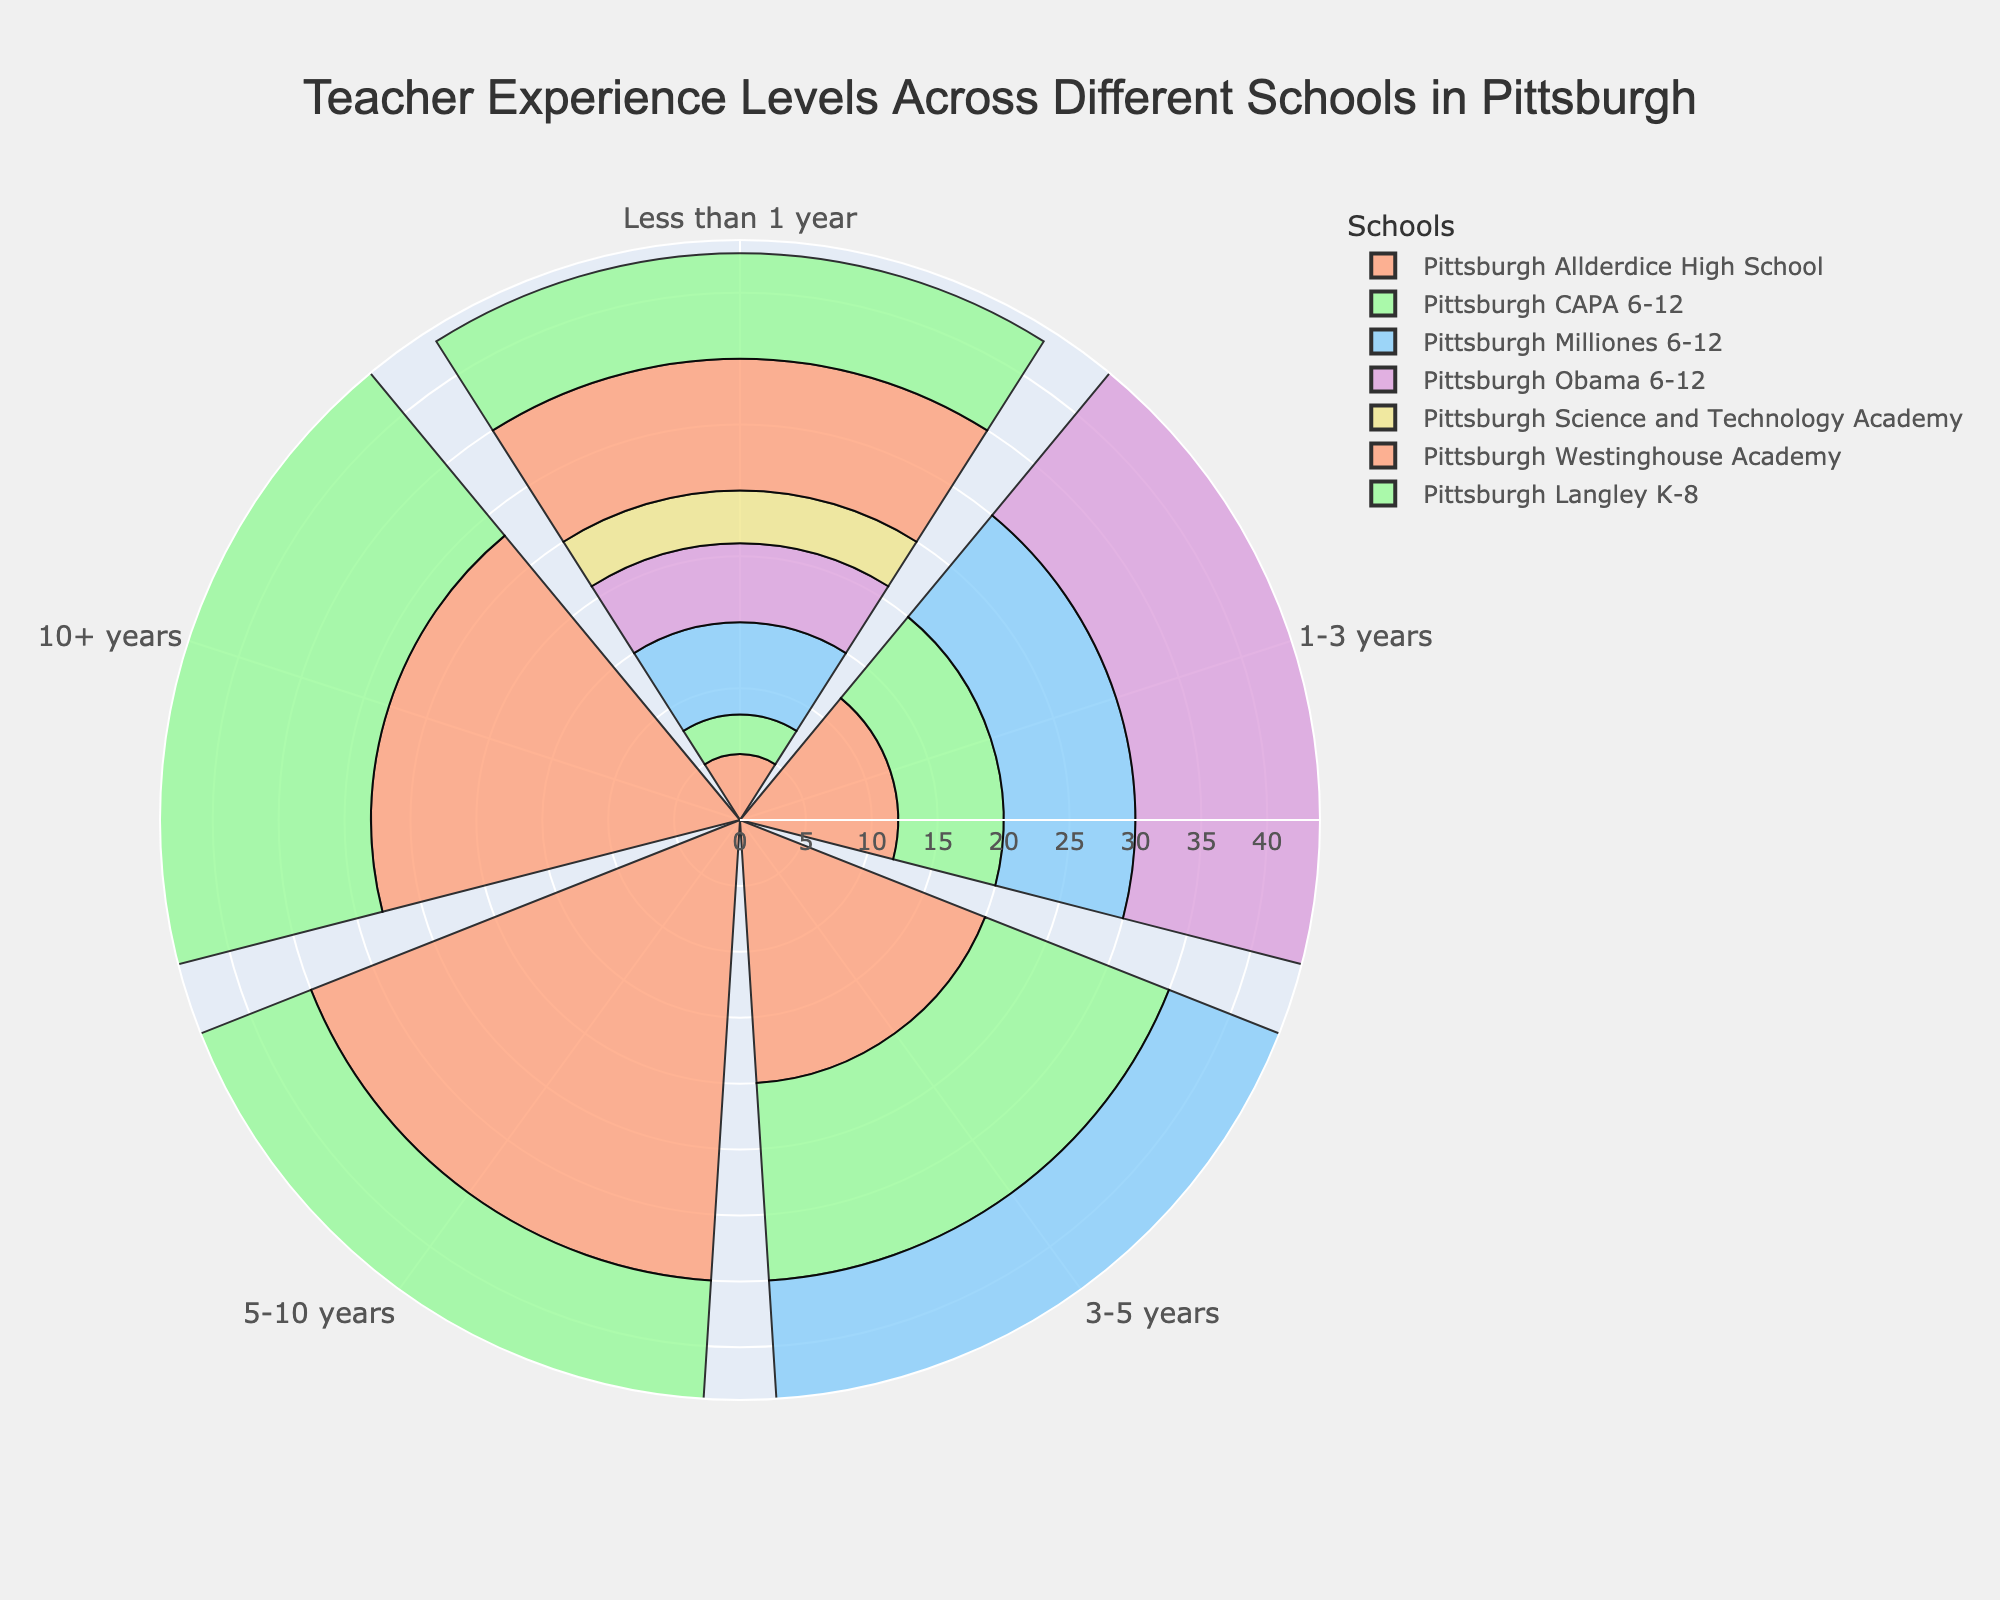What is the title of the figure? The title is prominently displayed at the top of the figure in larger, bold text.
Answer: Teacher Experience Levels Across Different Schools in Pittsburgh How many schools are represented in the figure? The figure's legend lists all the schools, and there are seven different colored segments representing each school.
Answer: Seven Which school has the highest number of teachers with more than 10 years of experience? By checking the length of the outermost segments in the rose chart, the school with the longest segment in the 10+ years category is Pittsburgh Westinghouse Academy.
Answer: Pittsburgh Westinghouse Academy For Pittsburgh CAPA 6-12, what is the total number of teachers with less than 5 years of experience? Add up the values from the segments representing "Less than 1 year," "1-3 years," and "3-5 years" for Pittsburgh CAPA 6-12: 3 + 8 + 15.
Answer: 26 Which school has the greatest difference in the number of teachers between the "1-3 years" and "5-10 years" experience categories? Calculate the differences for each school: 
Pittsburgh Allderdice High School = 35 - 12 = 23, 
Pittsburgh CAPA 6-12 = 25 - 8 = 17, 
Pittsburgh Milliones 6-12 = 25 - 10 = 15, 
Pittsburgh Obama 6-12 = 30 - 15 = 15, 
Pittsburgh Science and Technology Academy = 28 - 10 = 18, 
Pittsburgh Westinghouse Academy = 35 - 18 = 17,
Pittsburgh Langley K-8 = 20 - 16 = 4;
Pittsburgh Allderdice High School has the greatest difference.
Answer: Pittsburgh Allderdice High School Which school has the smallest portion of teachers with "Less than 1 year" of experience? The smallest innermost segment represents the school with the least teachers in this category, which is Pittsburgh CAPA 6-12.
Answer: Pittsburgh CAPA 6-12 Between Pittsburgh Science and Technology Academy and Pittsburgh Milliones 6-12, which school has more teachers with "5-10 years" of experience? Compare the length of the 5-10 years segments for both schools; Pittsburgh Science and Technology Academy has 28 while Pittsburgh Milliones 6-12 has 25.
Answer: Pittsburgh Science and Technology Academy What is the average number of teachers with "3-5 years" of experience across all schools? Sum the values of the 3-5 years segments for all schools and divide by the number of schools: 
(20 + 15 + 13 + 18 + 12 + 22 + 20) / 7 
= 120 / 7 
= approximately 17.14.
Answer: approximately 17.14 